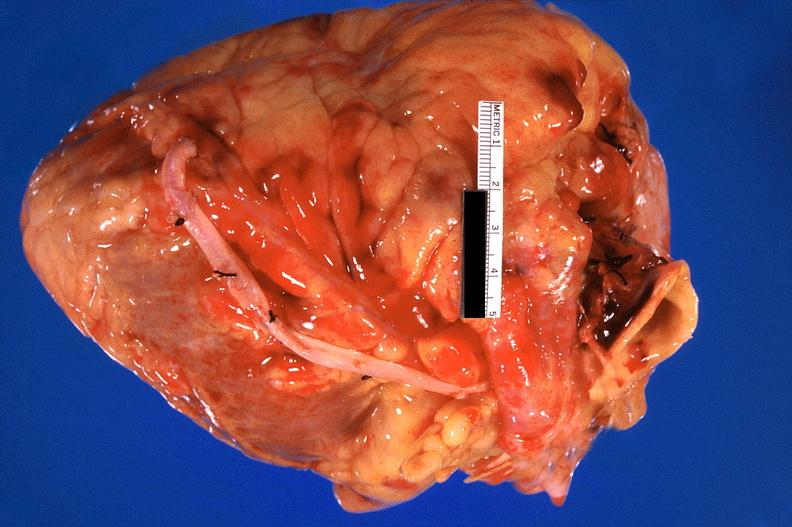does natural color show heart, recent coronary artery bypass graft?
Answer the question using a single word or phrase. No 